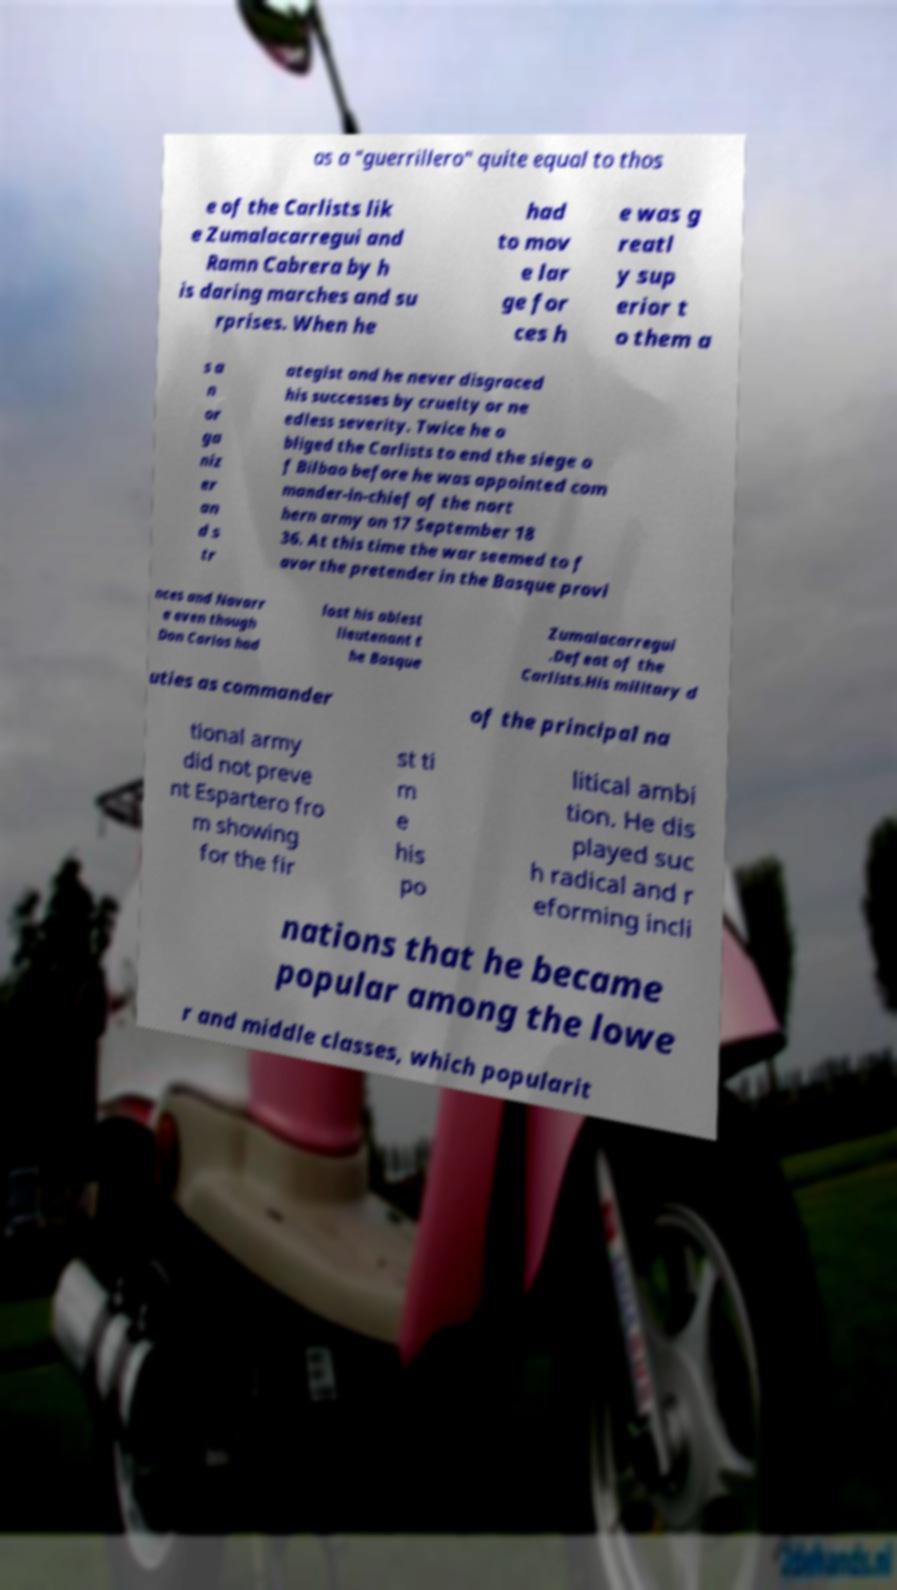Can you accurately transcribe the text from the provided image for me? as a "guerrillero" quite equal to thos e of the Carlists lik e Zumalacarregui and Ramn Cabrera by h is daring marches and su rprises. When he had to mov e lar ge for ces h e was g reatl y sup erior t o them a s a n or ga niz er an d s tr ategist and he never disgraced his successes by cruelty or ne edless severity. Twice he o bliged the Carlists to end the siege o f Bilbao before he was appointed com mander-in-chief of the nort hern army on 17 September 18 36. At this time the war seemed to f avor the pretender in the Basque provi nces and Navarr e even though Don Carlos had lost his ablest lieutenant t he Basque Zumalacarregui .Defeat of the Carlists.His military d uties as commander of the principal na tional army did not preve nt Espartero fro m showing for the fir st ti m e his po litical ambi tion. He dis played suc h radical and r eforming incli nations that he became popular among the lowe r and middle classes, which popularit 